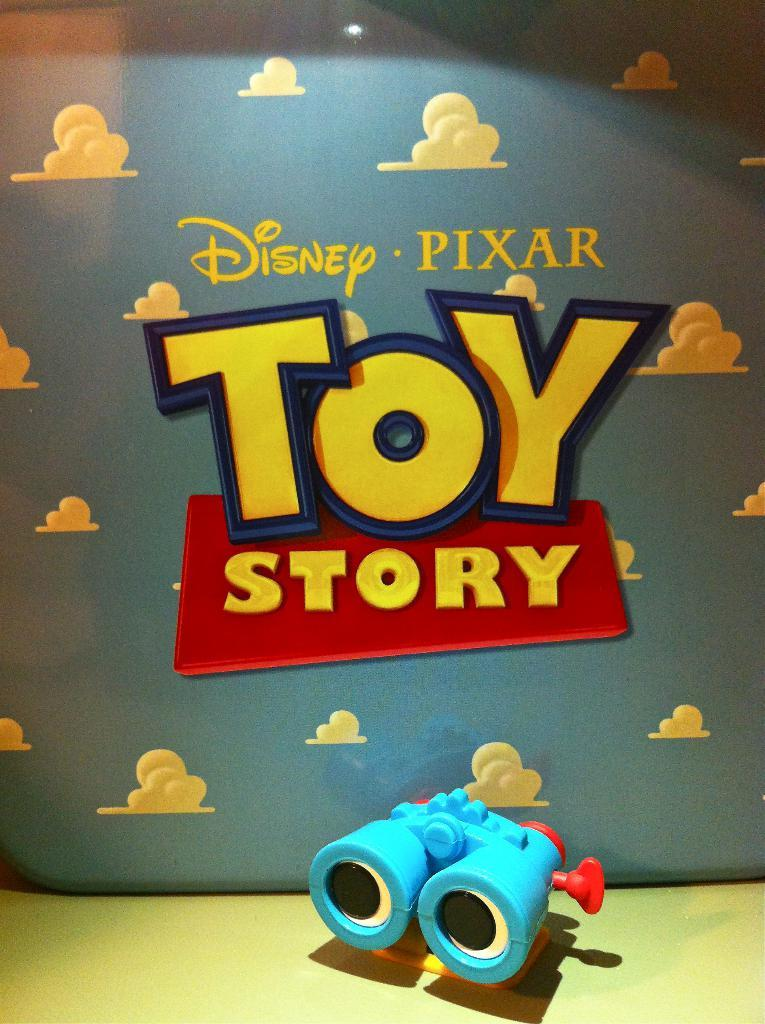<image>
Write a terse but informative summary of the picture. a ToyStory movie poster with the Disney logo on it 